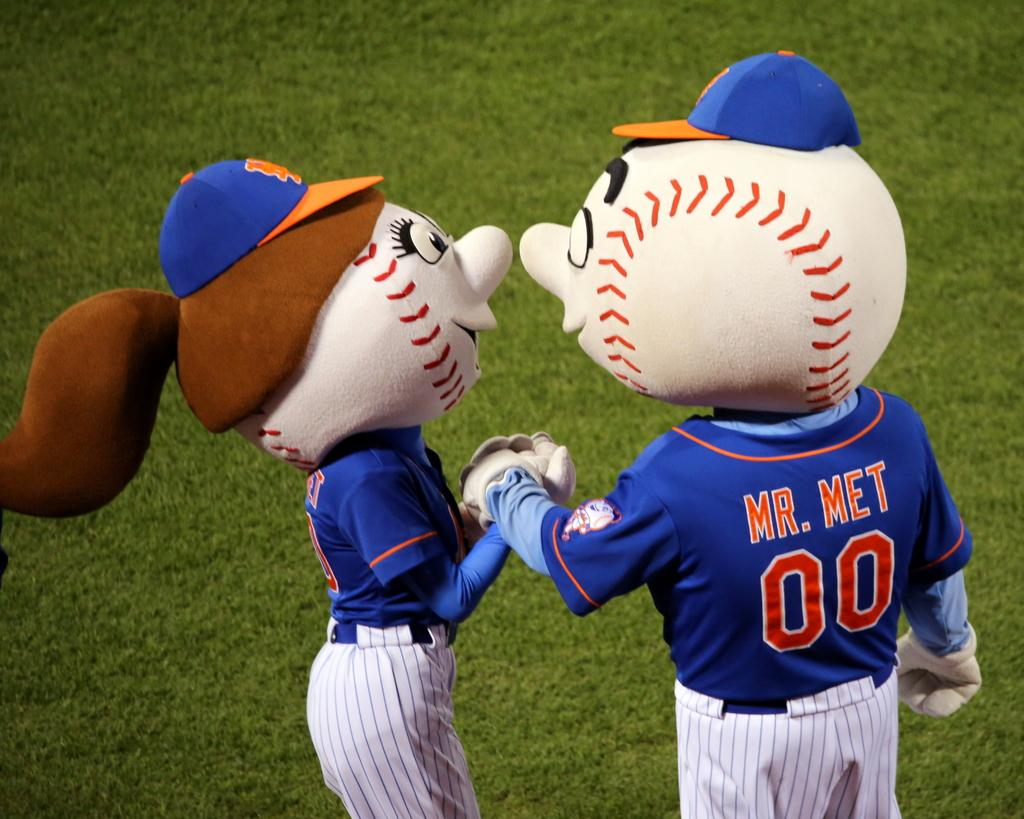<image>
Describe the image concisely. Two baseball mascots, Mr. Met and a female mascot kissing on the field. 